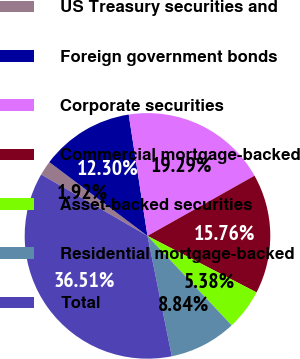Convert chart to OTSL. <chart><loc_0><loc_0><loc_500><loc_500><pie_chart><fcel>US Treasury securities and<fcel>Foreign government bonds<fcel>Corporate securities<fcel>Commercial mortgage-backed<fcel>Asset-backed securities<fcel>Residential mortgage-backed<fcel>Total<nl><fcel>1.92%<fcel>12.3%<fcel>19.29%<fcel>15.76%<fcel>5.38%<fcel>8.84%<fcel>36.51%<nl></chart> 